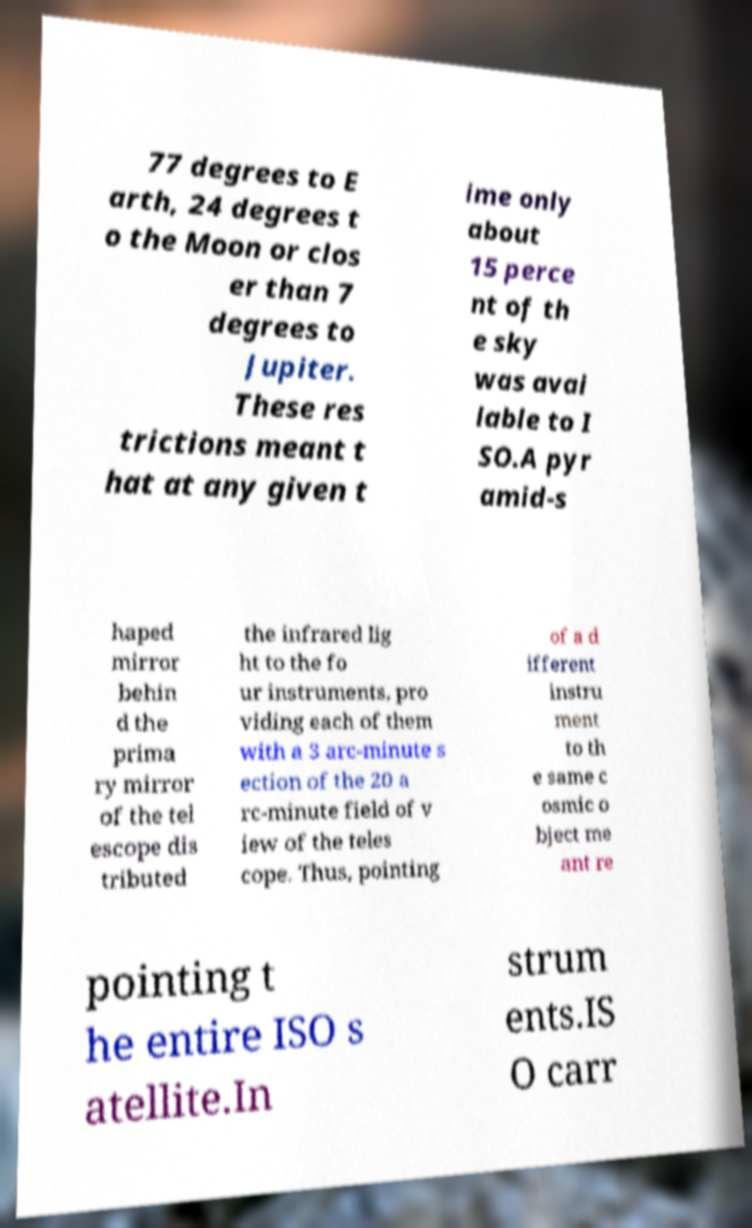Can you accurately transcribe the text from the provided image for me? 77 degrees to E arth, 24 degrees t o the Moon or clos er than 7 degrees to Jupiter. These res trictions meant t hat at any given t ime only about 15 perce nt of th e sky was avai lable to I SO.A pyr amid-s haped mirror behin d the prima ry mirror of the tel escope dis tributed the infrared lig ht to the fo ur instruments, pro viding each of them with a 3 arc-minute s ection of the 20 a rc-minute field of v iew of the teles cope. Thus, pointing of a d ifferent instru ment to th e same c osmic o bject me ant re pointing t he entire ISO s atellite.In strum ents.IS O carr 